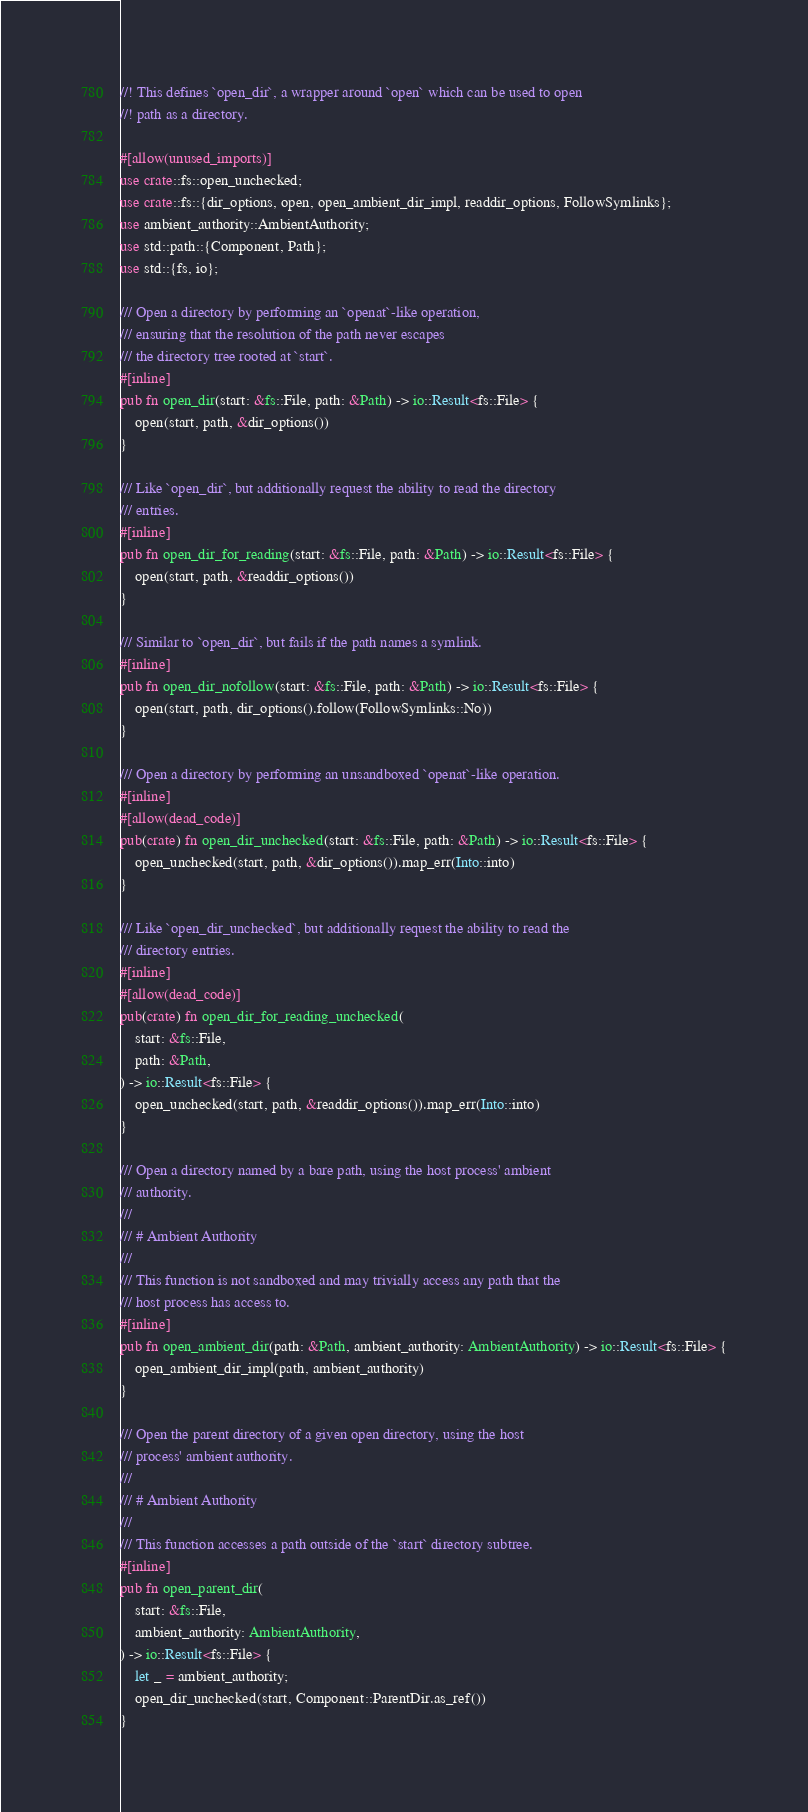<code> <loc_0><loc_0><loc_500><loc_500><_Rust_>//! This defines `open_dir`, a wrapper around `open` which can be used to open
//! path as a directory.

#[allow(unused_imports)]
use crate::fs::open_unchecked;
use crate::fs::{dir_options, open, open_ambient_dir_impl, readdir_options, FollowSymlinks};
use ambient_authority::AmbientAuthority;
use std::path::{Component, Path};
use std::{fs, io};

/// Open a directory by performing an `openat`-like operation,
/// ensuring that the resolution of the path never escapes
/// the directory tree rooted at `start`.
#[inline]
pub fn open_dir(start: &fs::File, path: &Path) -> io::Result<fs::File> {
    open(start, path, &dir_options())
}

/// Like `open_dir`, but additionally request the ability to read the directory
/// entries.
#[inline]
pub fn open_dir_for_reading(start: &fs::File, path: &Path) -> io::Result<fs::File> {
    open(start, path, &readdir_options())
}

/// Similar to `open_dir`, but fails if the path names a symlink.
#[inline]
pub fn open_dir_nofollow(start: &fs::File, path: &Path) -> io::Result<fs::File> {
    open(start, path, dir_options().follow(FollowSymlinks::No))
}

/// Open a directory by performing an unsandboxed `openat`-like operation.
#[inline]
#[allow(dead_code)]
pub(crate) fn open_dir_unchecked(start: &fs::File, path: &Path) -> io::Result<fs::File> {
    open_unchecked(start, path, &dir_options()).map_err(Into::into)
}

/// Like `open_dir_unchecked`, but additionally request the ability to read the
/// directory entries.
#[inline]
#[allow(dead_code)]
pub(crate) fn open_dir_for_reading_unchecked(
    start: &fs::File,
    path: &Path,
) -> io::Result<fs::File> {
    open_unchecked(start, path, &readdir_options()).map_err(Into::into)
}

/// Open a directory named by a bare path, using the host process' ambient
/// authority.
///
/// # Ambient Authority
///
/// This function is not sandboxed and may trivially access any path that the
/// host process has access to.
#[inline]
pub fn open_ambient_dir(path: &Path, ambient_authority: AmbientAuthority) -> io::Result<fs::File> {
    open_ambient_dir_impl(path, ambient_authority)
}

/// Open the parent directory of a given open directory, using the host
/// process' ambient authority.
///
/// # Ambient Authority
///
/// This function accesses a path outside of the `start` directory subtree.
#[inline]
pub fn open_parent_dir(
    start: &fs::File,
    ambient_authority: AmbientAuthority,
) -> io::Result<fs::File> {
    let _ = ambient_authority;
    open_dir_unchecked(start, Component::ParentDir.as_ref())
}
</code> 